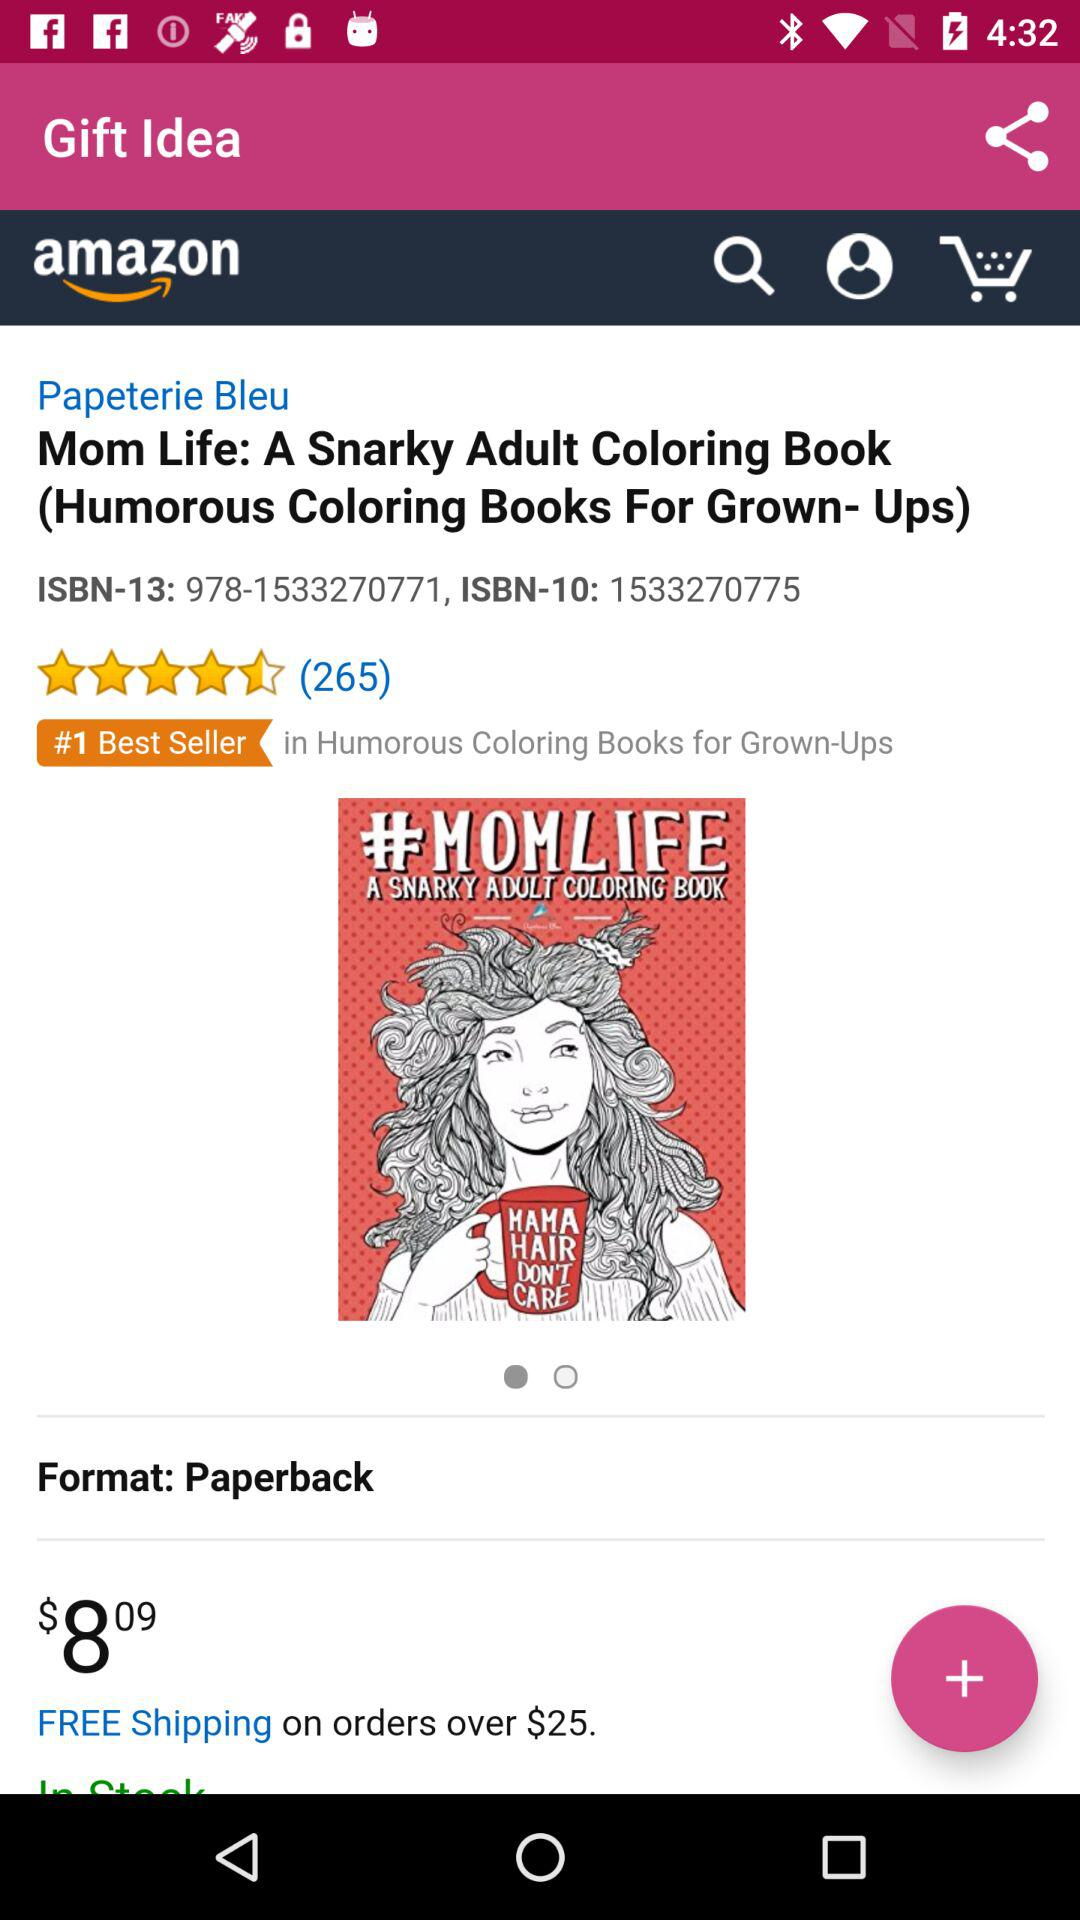What is the value for free shipping? Free shipping is available on orders over $25. 